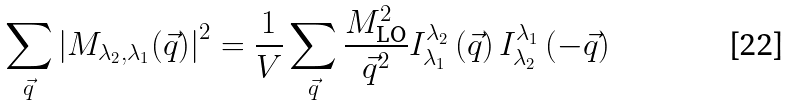<formula> <loc_0><loc_0><loc_500><loc_500>\sum _ { \vec { q } } \left | M _ { \lambda _ { 2 } , \lambda _ { 1 } } ( \vec { q } ) \right | ^ { 2 } = \frac { 1 } { V } \sum _ { \vec { q } } \frac { M _ { \text {LO} } ^ { 2 } } { \vec { q } ^ { 2 } } I ^ { \lambda _ { 2 } } _ { \lambda _ { 1 } } \left ( \vec { q } \right ) I ^ { \lambda _ { 1 } } _ { \lambda _ { 2 } } \left ( - \vec { q } \right )</formula> 